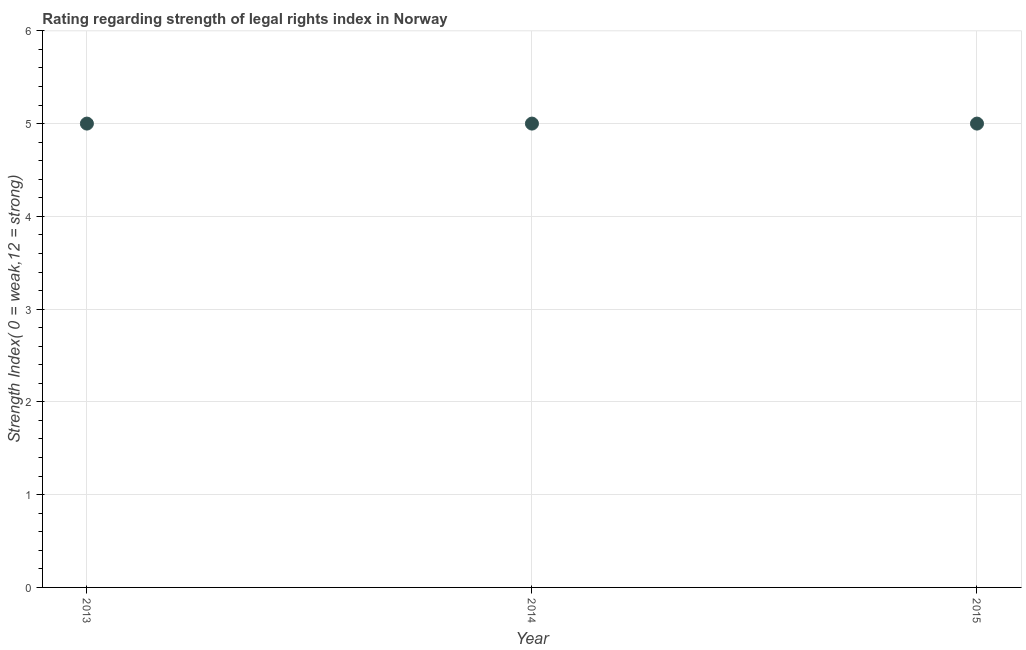What is the strength of legal rights index in 2015?
Provide a short and direct response. 5. Across all years, what is the maximum strength of legal rights index?
Offer a terse response. 5. Across all years, what is the minimum strength of legal rights index?
Provide a short and direct response. 5. In which year was the strength of legal rights index maximum?
Ensure brevity in your answer.  2013. What is the sum of the strength of legal rights index?
Offer a terse response. 15. What is the median strength of legal rights index?
Keep it short and to the point. 5. Is the difference between the strength of legal rights index in 2014 and 2015 greater than the difference between any two years?
Offer a very short reply. Yes. What is the difference between the highest and the second highest strength of legal rights index?
Your response must be concise. 0. What is the difference between the highest and the lowest strength of legal rights index?
Ensure brevity in your answer.  0. Does the strength of legal rights index monotonically increase over the years?
Give a very brief answer. No. How many dotlines are there?
Ensure brevity in your answer.  1. What is the difference between two consecutive major ticks on the Y-axis?
Ensure brevity in your answer.  1. Does the graph contain any zero values?
Offer a terse response. No. Does the graph contain grids?
Provide a short and direct response. Yes. What is the title of the graph?
Your response must be concise. Rating regarding strength of legal rights index in Norway. What is the label or title of the X-axis?
Offer a very short reply. Year. What is the label or title of the Y-axis?
Give a very brief answer. Strength Index( 0 = weak,12 = strong). What is the Strength Index( 0 = weak,12 = strong) in 2013?
Ensure brevity in your answer.  5. What is the difference between the Strength Index( 0 = weak,12 = strong) in 2014 and 2015?
Ensure brevity in your answer.  0. What is the ratio of the Strength Index( 0 = weak,12 = strong) in 2013 to that in 2014?
Provide a short and direct response. 1. What is the ratio of the Strength Index( 0 = weak,12 = strong) in 2013 to that in 2015?
Offer a very short reply. 1. What is the ratio of the Strength Index( 0 = weak,12 = strong) in 2014 to that in 2015?
Your answer should be compact. 1. 